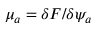<formula> <loc_0><loc_0><loc_500><loc_500>\mu _ { a } = \delta F / \delta \psi _ { a }</formula> 